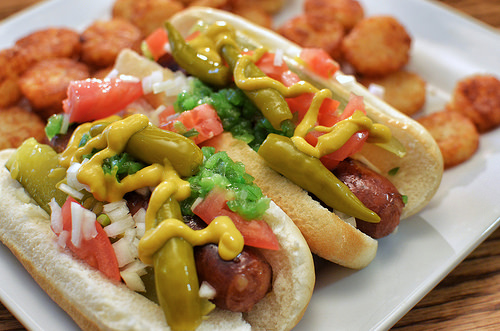<image>
Can you confirm if the hot dog is on the bun? Yes. Looking at the image, I can see the hot dog is positioned on top of the bun, with the bun providing support. Is there a hot dog behind the table? No. The hot dog is not behind the table. From this viewpoint, the hot dog appears to be positioned elsewhere in the scene. 